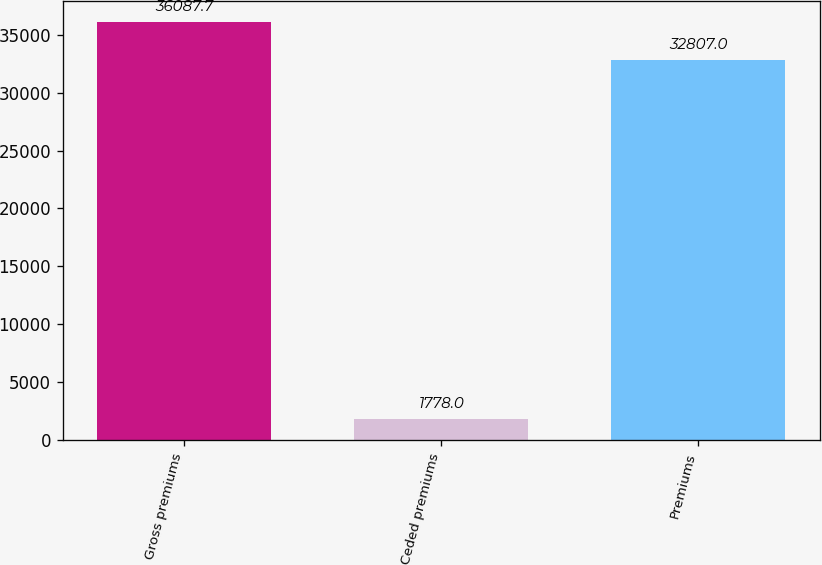<chart> <loc_0><loc_0><loc_500><loc_500><bar_chart><fcel>Gross premiums<fcel>Ceded premiums<fcel>Premiums<nl><fcel>36087.7<fcel>1778<fcel>32807<nl></chart> 